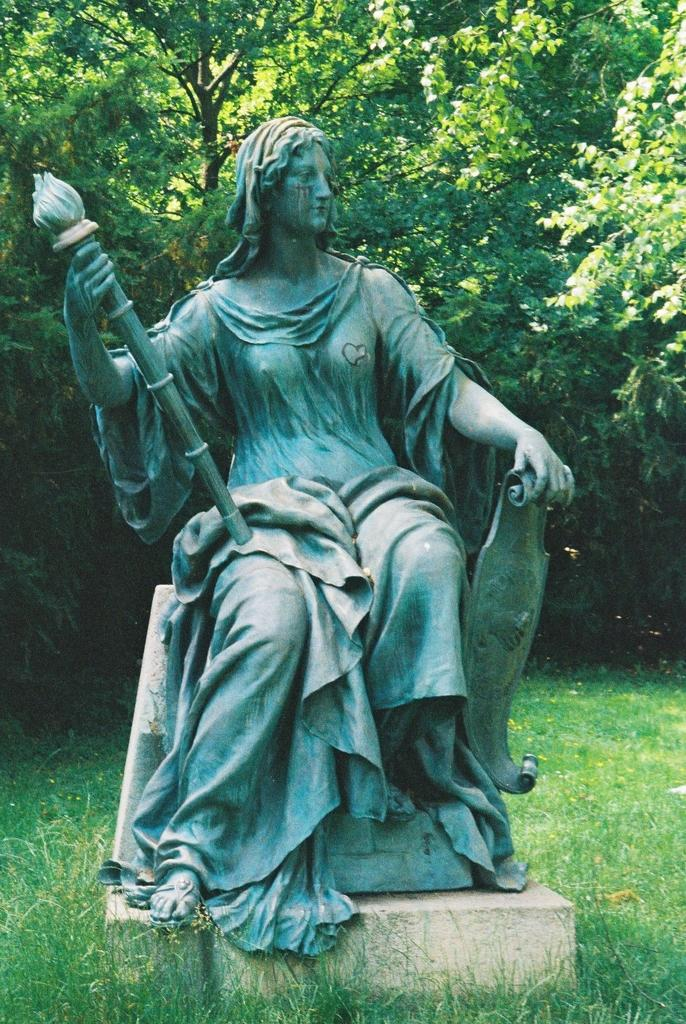What is the main subject in the center of the image? There is a sculpture in the center of the image. What type of natural ground cover is present at the bottom of the image? There is grass at the bottom of the image. What can be seen in the background of the image? There are trees visible in the background of the image. What type of songs can be heard being sung by the apple in the image? There is no apple present in the image, and therefore no singing can be observed. Can you tell me how many times the whistle is blown in the image? There is no whistle present in the image, and therefore no whistle blowing can be observed. 